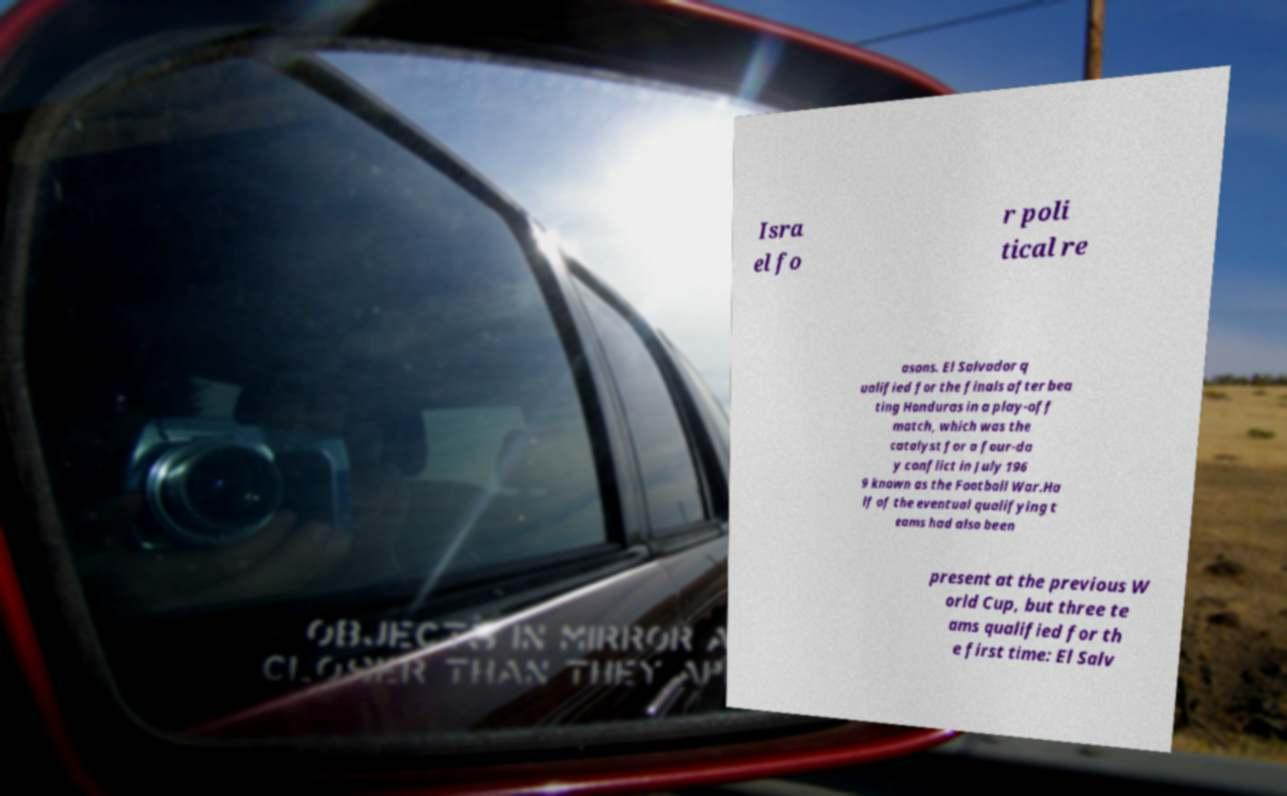Could you extract and type out the text from this image? Isra el fo r poli tical re asons. El Salvador q ualified for the finals after bea ting Honduras in a play-off match, which was the catalyst for a four-da y conflict in July 196 9 known as the Football War.Ha lf of the eventual qualifying t eams had also been present at the previous W orld Cup, but three te ams qualified for th e first time: El Salv 